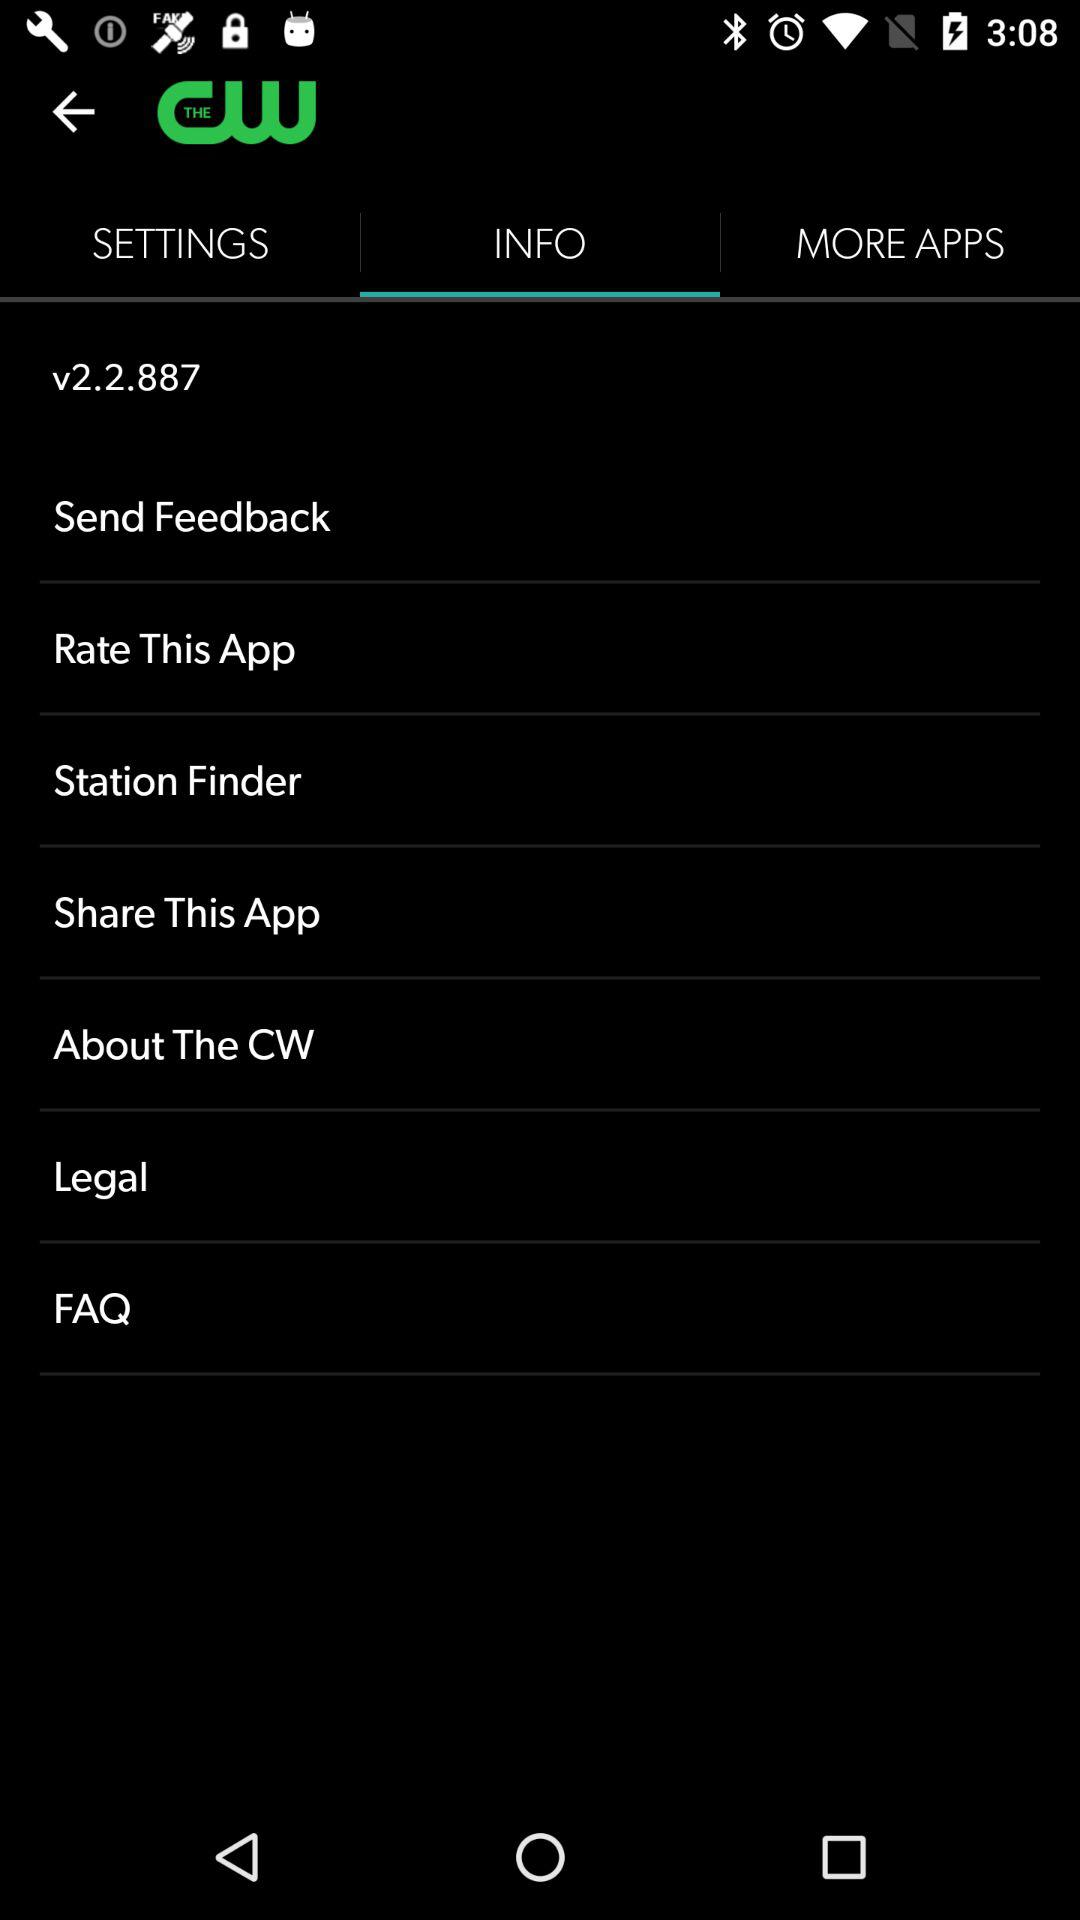What is the version number? The version number is 2.2.887. 